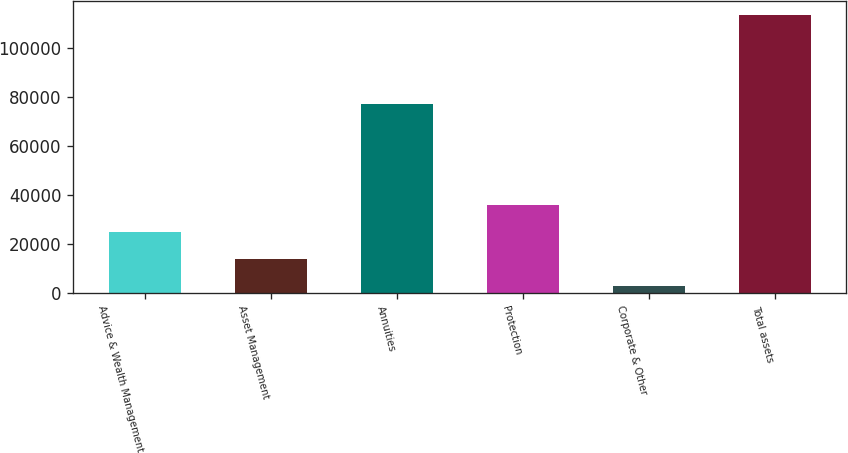Convert chart to OTSL. <chart><loc_0><loc_0><loc_500><loc_500><bar_chart><fcel>Advice & Wealth Management<fcel>Asset Management<fcel>Annuities<fcel>Protection<fcel>Corporate & Other<fcel>Total assets<nl><fcel>25094.8<fcel>14010.4<fcel>77037<fcel>36179.2<fcel>2926<fcel>113770<nl></chart> 